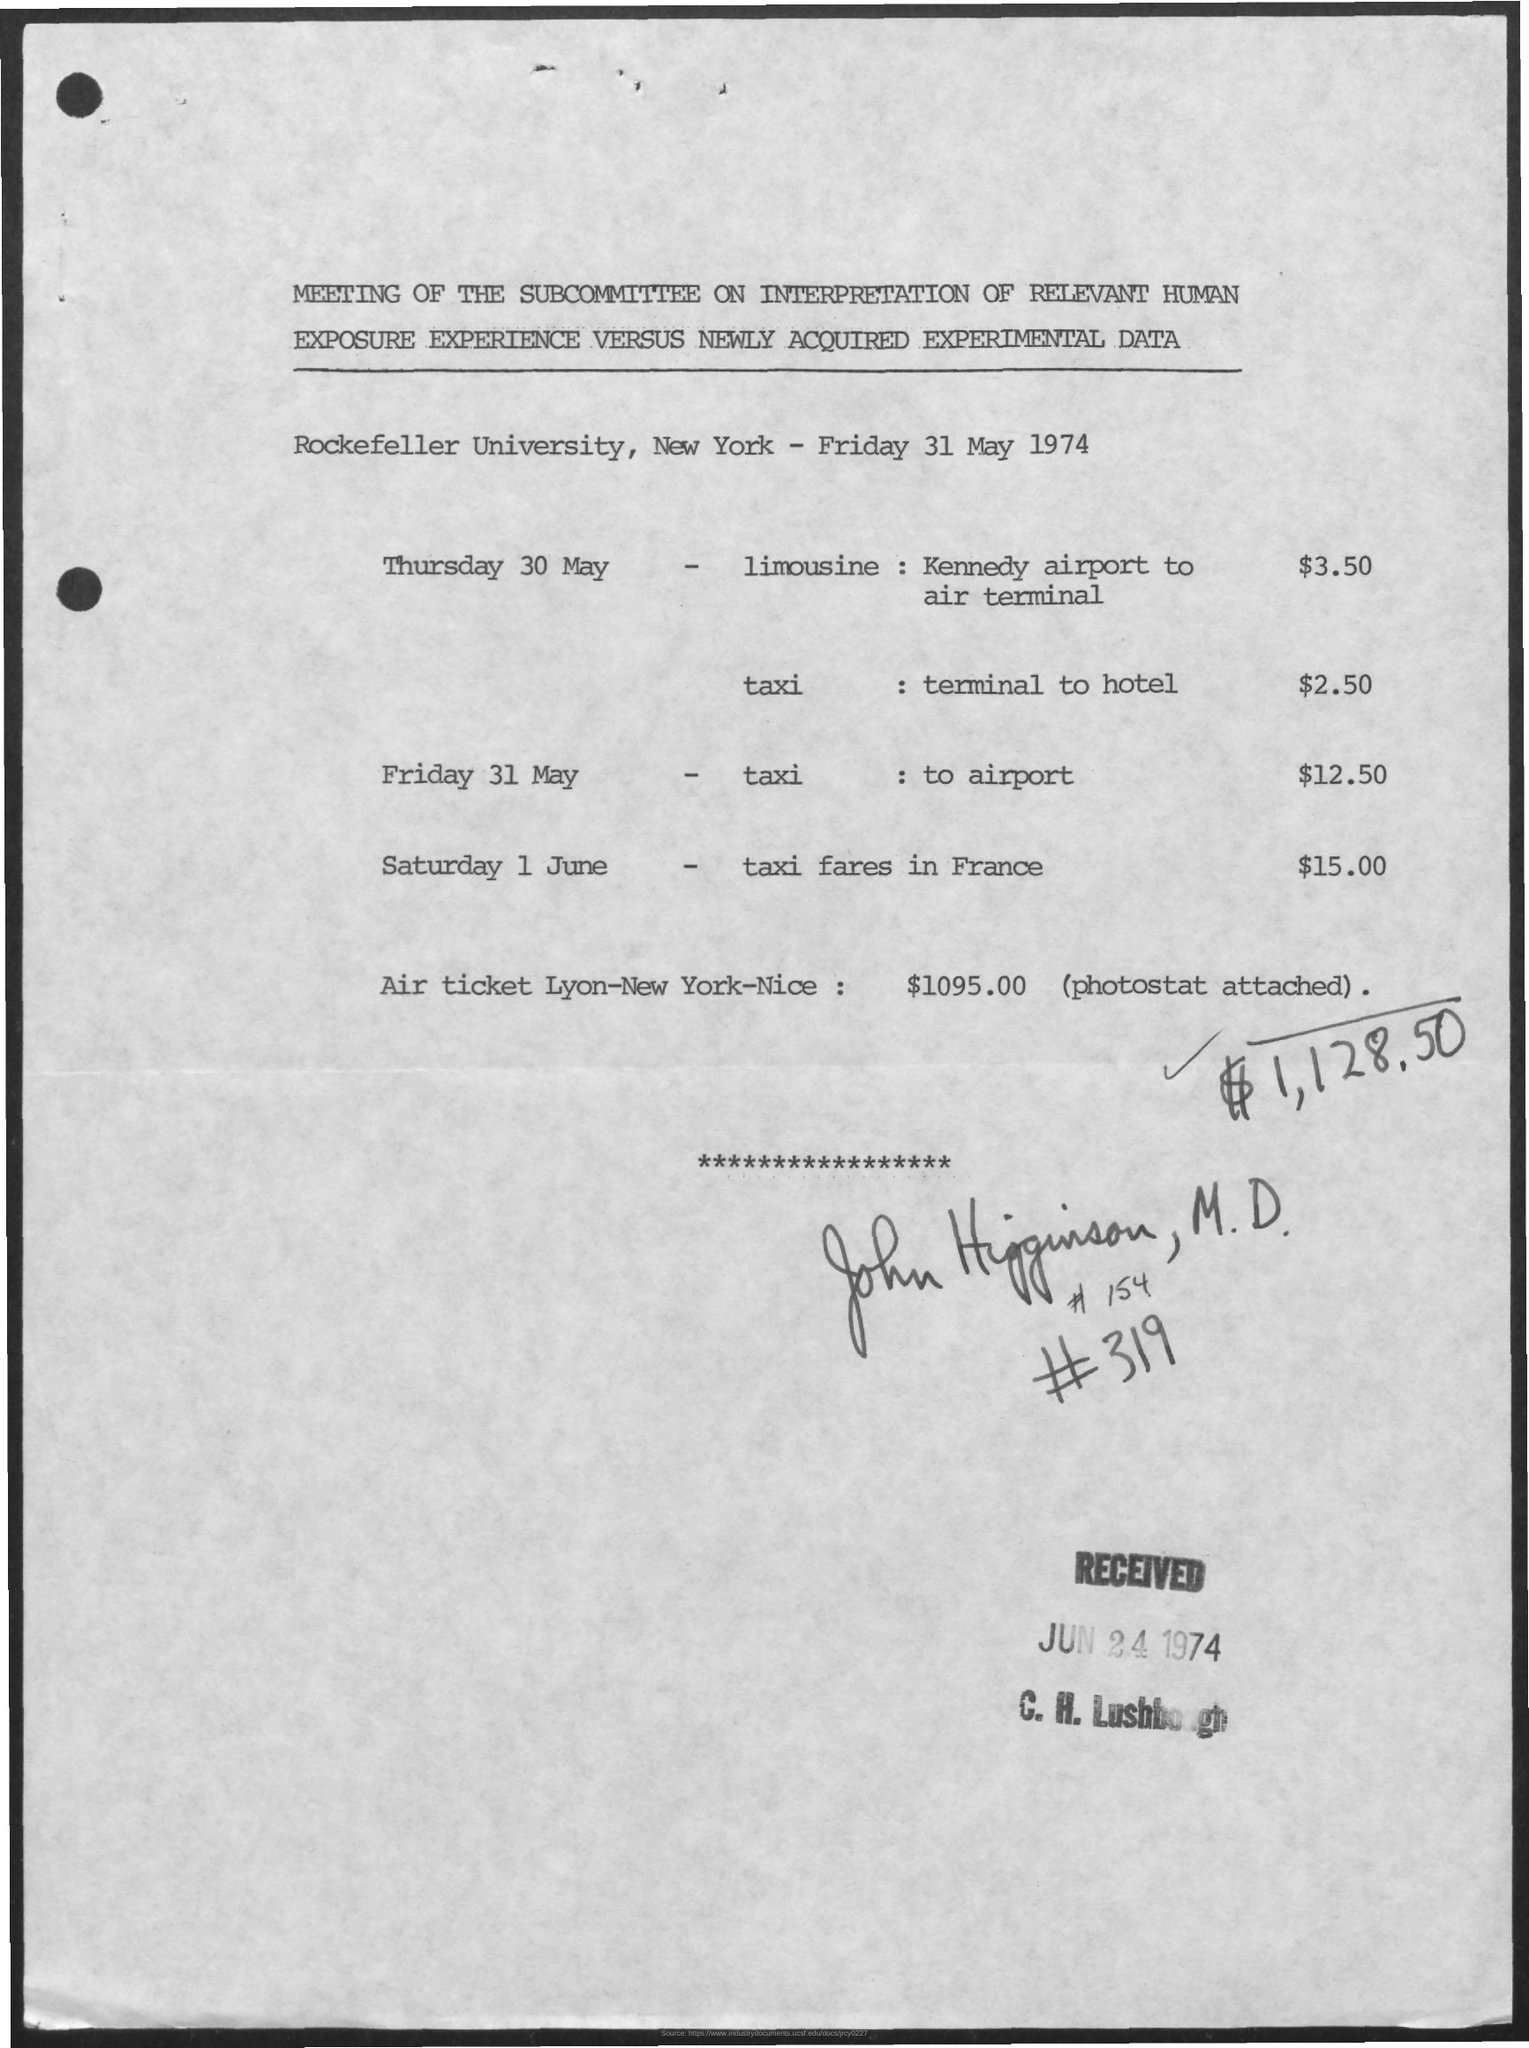Can you provide insight into what kind of expenses are listed on this document? The document lists transportation costs including limousine service, taxi fares within the city, and an air ticket that connects Lyon, New York, and Nice. The expenses are for different days surrounding the date of the meeting, and the document includes a total amount possibly for reimbursement or record-keeping purposes. 